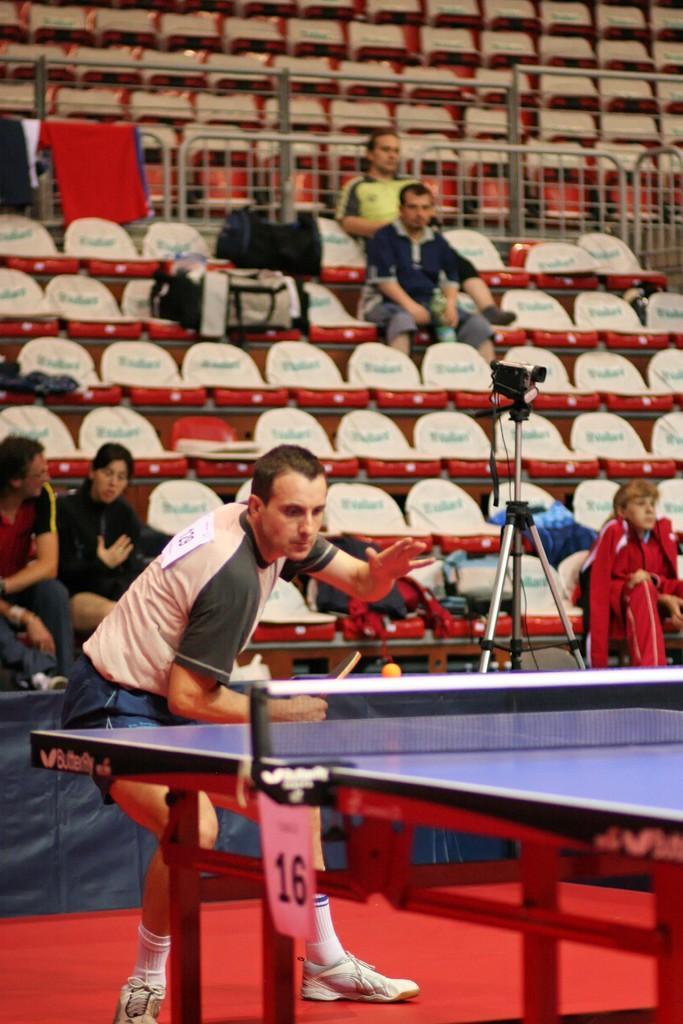In one or two sentences, can you explain what this image depicts? Here we can see a man is standing on the floor and playing table tennis and this is table tennis board. In the background there is a camera on a stand,few persons are sitting on the chairs,clothes on a fence and bags on the chairs. 